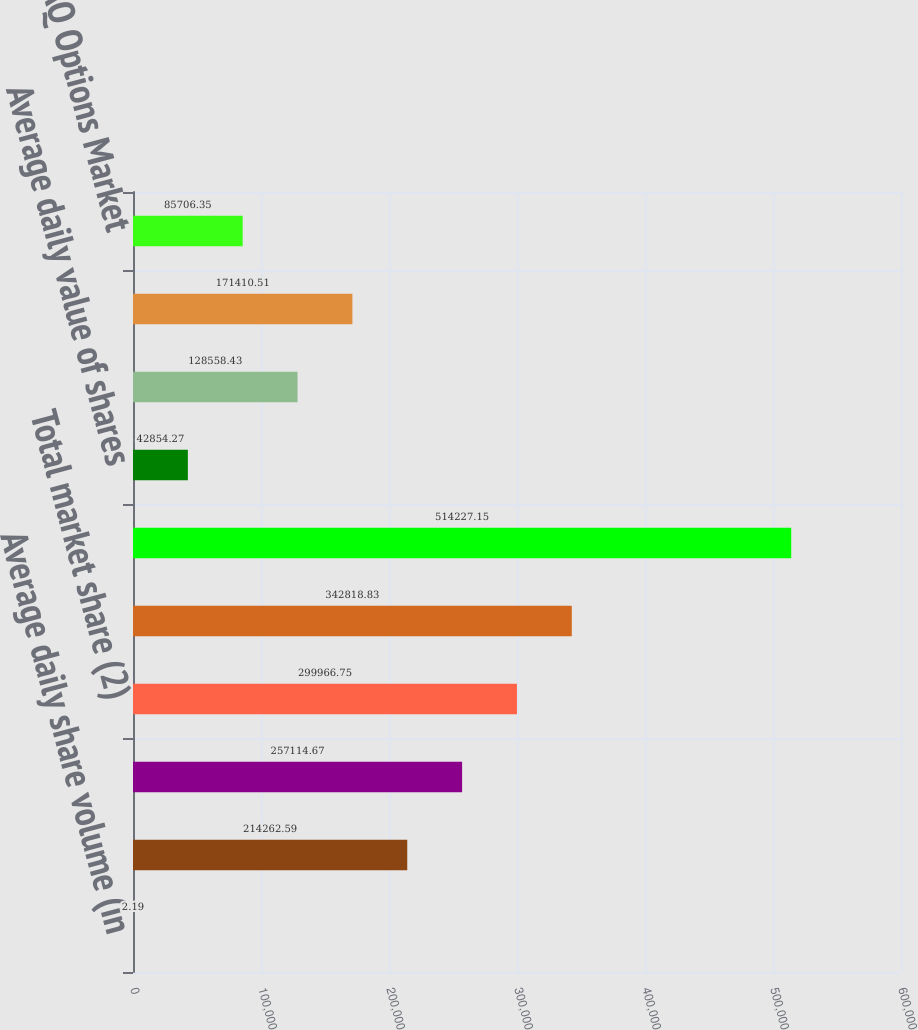Convert chart. <chart><loc_0><loc_0><loc_500><loc_500><bar_chart><fcel>Average daily share volume (in<fcel>Matched market share executed<fcel>Market share reported to the<fcel>Total market share (2)<fcel>Matched share volume (in<fcel>Average daily number of equity<fcel>Average daily value of shares<fcel>Average daily volume (in<fcel>NASDAQ OMX PHLX matched market<fcel>The NASDAQ Options Market<nl><fcel>2.19<fcel>214263<fcel>257115<fcel>299967<fcel>342819<fcel>514227<fcel>42854.3<fcel>128558<fcel>171411<fcel>85706.4<nl></chart> 